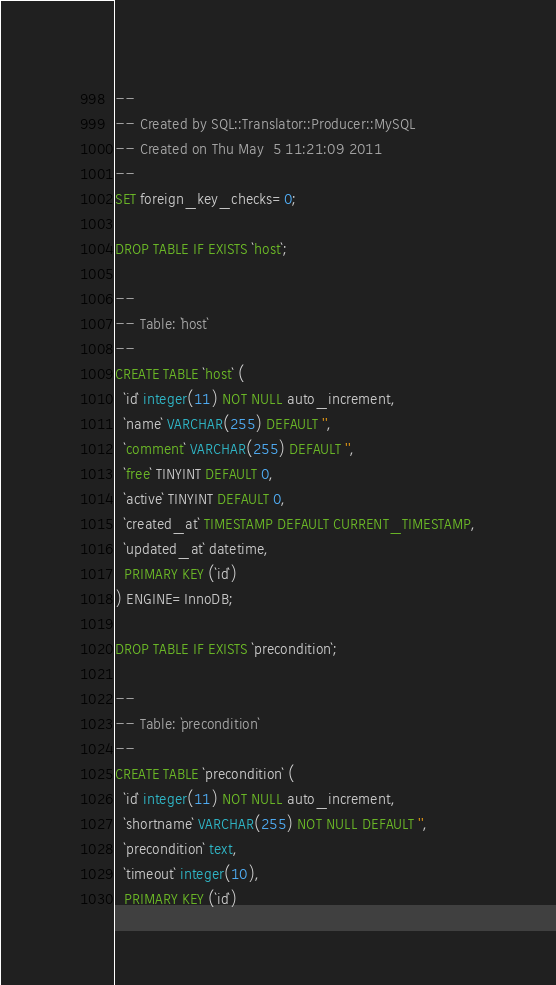<code> <loc_0><loc_0><loc_500><loc_500><_SQL_>-- 
-- Created by SQL::Translator::Producer::MySQL
-- Created on Thu May  5 11:21:09 2011
-- 
SET foreign_key_checks=0;

DROP TABLE IF EXISTS `host`;

--
-- Table: `host`
--
CREATE TABLE `host` (
  `id` integer(11) NOT NULL auto_increment,
  `name` VARCHAR(255) DEFAULT '',
  `comment` VARCHAR(255) DEFAULT '',
  `free` TINYINT DEFAULT 0,
  `active` TINYINT DEFAULT 0,
  `created_at` TIMESTAMP DEFAULT CURRENT_TIMESTAMP,
  `updated_at` datetime,
  PRIMARY KEY (`id`)
) ENGINE=InnoDB;

DROP TABLE IF EXISTS `precondition`;

--
-- Table: `precondition`
--
CREATE TABLE `precondition` (
  `id` integer(11) NOT NULL auto_increment,
  `shortname` VARCHAR(255) NOT NULL DEFAULT '',
  `precondition` text,
  `timeout` integer(10),
  PRIMARY KEY (`id`)</code> 